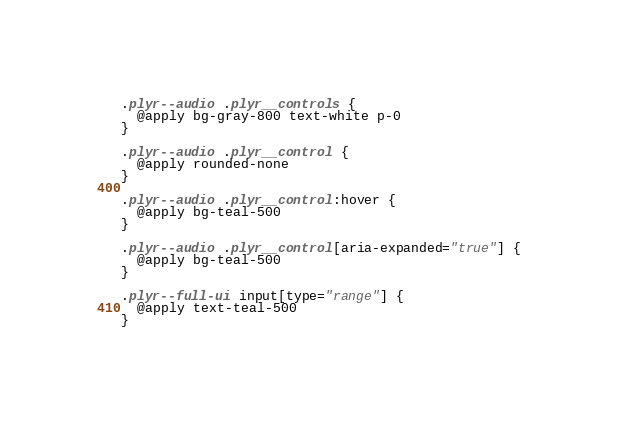Convert code to text. <code><loc_0><loc_0><loc_500><loc_500><_CSS_>
.plyr--audio .plyr__controls {
  @apply bg-gray-800 text-white p-0
}

.plyr--audio .plyr__control {
  @apply rounded-none
}

.plyr--audio .plyr__control:hover {
  @apply bg-teal-500
}

.plyr--audio .plyr__control[aria-expanded="true"] {
  @apply bg-teal-500
}

.plyr--full-ui input[type="range"] {
  @apply text-teal-500
}</code> 